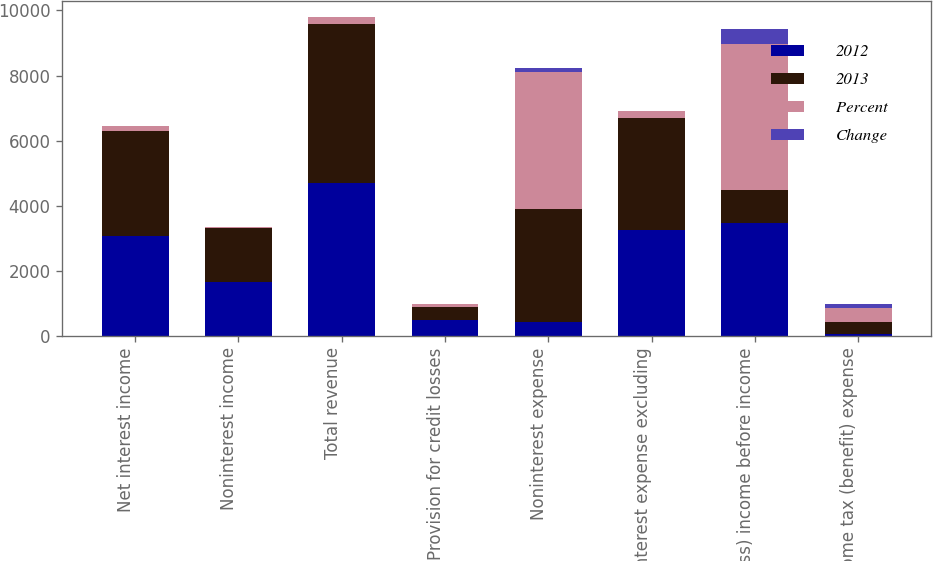Convert chart. <chart><loc_0><loc_0><loc_500><loc_500><stacked_bar_chart><ecel><fcel>Net interest income<fcel>Noninterest income<fcel>Total revenue<fcel>Provision for credit losses<fcel>Noninterest expense<fcel>Noninterest expense excluding<fcel>(Loss) income before income<fcel>Income tax (benefit) expense<nl><fcel>2012<fcel>3058<fcel>1632<fcel>4690<fcel>479<fcel>423<fcel>3244<fcel>3468<fcel>42<nl><fcel>2013<fcel>3227<fcel>1667<fcel>4894<fcel>413<fcel>3457<fcel>3457<fcel>1024<fcel>381<nl><fcel>Percent<fcel>169<fcel>35<fcel>204<fcel>66<fcel>4222<fcel>213<fcel>4492<fcel>423<nl><fcel>Change<fcel>5<fcel>2<fcel>4<fcel>16<fcel>122<fcel>6<fcel>439<fcel>111<nl></chart> 